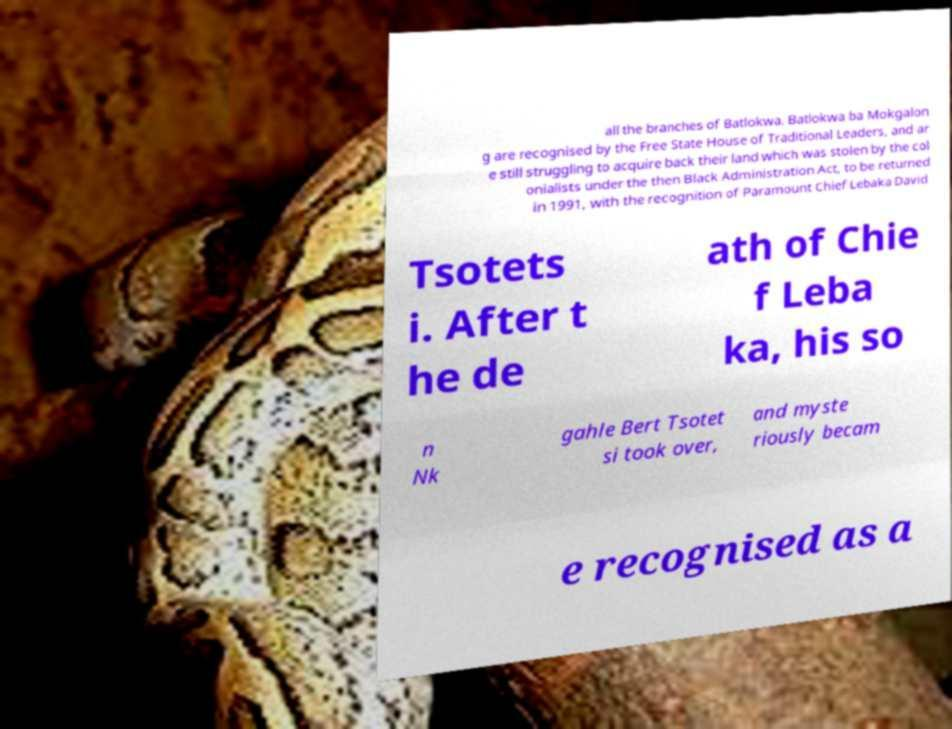Please identify and transcribe the text found in this image. all the branches of Batlokwa. Batlokwa ba Mokgalon g are recognised by the Free State House of Traditional Leaders, and ar e still struggling to acquire back their land which was stolen by the col onialists under the then Black Administration Act, to be returned in 1991, with the recognition of Paramount Chief Lebaka David Tsotets i. After t he de ath of Chie f Leba ka, his so n Nk gahle Bert Tsotet si took over, and myste riously becam e recognised as a 